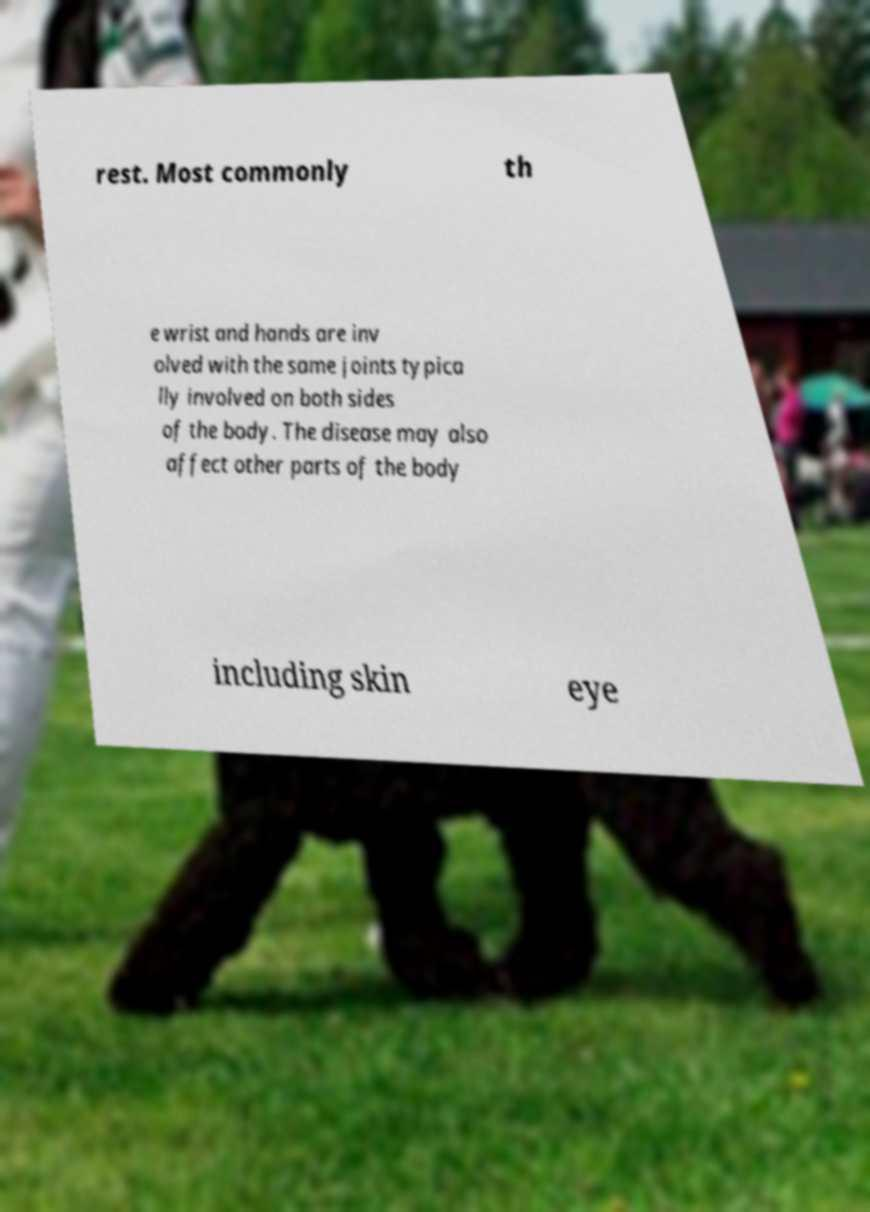What messages or text are displayed in this image? I need them in a readable, typed format. rest. Most commonly th e wrist and hands are inv olved with the same joints typica lly involved on both sides of the body. The disease may also affect other parts of the body including skin eye 